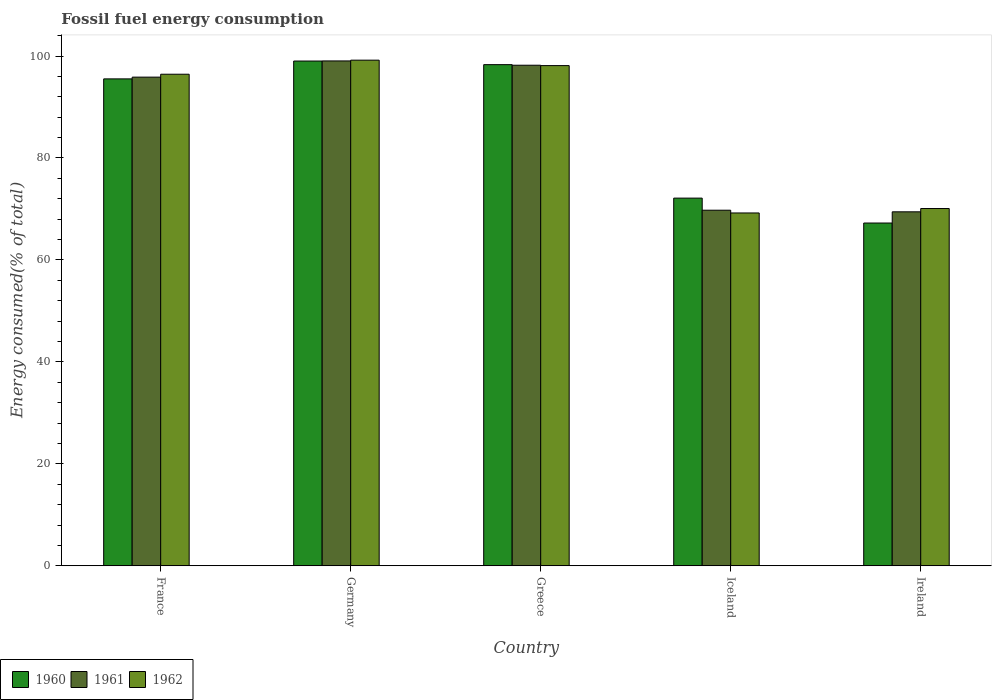How many different coloured bars are there?
Make the answer very short. 3. Are the number of bars per tick equal to the number of legend labels?
Your response must be concise. Yes. How many bars are there on the 1st tick from the right?
Provide a short and direct response. 3. What is the label of the 2nd group of bars from the left?
Make the answer very short. Germany. What is the percentage of energy consumed in 1960 in Ireland?
Give a very brief answer. 67.24. Across all countries, what is the maximum percentage of energy consumed in 1962?
Keep it short and to the point. 99.19. Across all countries, what is the minimum percentage of energy consumed in 1961?
Your answer should be very brief. 69.44. In which country was the percentage of energy consumed in 1961 maximum?
Provide a succinct answer. Germany. In which country was the percentage of energy consumed in 1961 minimum?
Offer a terse response. Ireland. What is the total percentage of energy consumed in 1961 in the graph?
Provide a succinct answer. 432.3. What is the difference between the percentage of energy consumed in 1962 in France and that in Iceland?
Offer a very short reply. 27.22. What is the difference between the percentage of energy consumed in 1961 in France and the percentage of energy consumed in 1960 in Greece?
Give a very brief answer. -2.45. What is the average percentage of energy consumed in 1960 per country?
Your answer should be compact. 86.44. What is the difference between the percentage of energy consumed of/in 1961 and percentage of energy consumed of/in 1960 in Iceland?
Ensure brevity in your answer.  -2.37. What is the ratio of the percentage of energy consumed in 1960 in Iceland to that in Ireland?
Provide a short and direct response. 1.07. What is the difference between the highest and the second highest percentage of energy consumed in 1962?
Ensure brevity in your answer.  -1.69. What is the difference between the highest and the lowest percentage of energy consumed in 1961?
Ensure brevity in your answer.  29.6. What does the 1st bar from the right in Ireland represents?
Your response must be concise. 1962. Is it the case that in every country, the sum of the percentage of energy consumed in 1961 and percentage of energy consumed in 1960 is greater than the percentage of energy consumed in 1962?
Your answer should be compact. Yes. How many countries are there in the graph?
Keep it short and to the point. 5. What is the difference between two consecutive major ticks on the Y-axis?
Your answer should be very brief. 20. Are the values on the major ticks of Y-axis written in scientific E-notation?
Ensure brevity in your answer.  No. Does the graph contain any zero values?
Provide a short and direct response. No. Does the graph contain grids?
Keep it short and to the point. No. How many legend labels are there?
Keep it short and to the point. 3. What is the title of the graph?
Ensure brevity in your answer.  Fossil fuel energy consumption. Does "1978" appear as one of the legend labels in the graph?
Your response must be concise. No. What is the label or title of the Y-axis?
Make the answer very short. Energy consumed(% of total). What is the Energy consumed(% of total) of 1960 in France?
Your answer should be compact. 95.52. What is the Energy consumed(% of total) in 1961 in France?
Give a very brief answer. 95.86. What is the Energy consumed(% of total) of 1962 in France?
Your answer should be very brief. 96.43. What is the Energy consumed(% of total) in 1960 in Germany?
Keep it short and to the point. 99.02. What is the Energy consumed(% of total) in 1961 in Germany?
Your answer should be very brief. 99.04. What is the Energy consumed(% of total) of 1962 in Germany?
Offer a very short reply. 99.19. What is the Energy consumed(% of total) in 1960 in Greece?
Your answer should be compact. 98.31. What is the Energy consumed(% of total) in 1961 in Greece?
Offer a very short reply. 98.2. What is the Energy consumed(% of total) of 1962 in Greece?
Offer a terse response. 98.12. What is the Energy consumed(% of total) in 1960 in Iceland?
Keep it short and to the point. 72.13. What is the Energy consumed(% of total) of 1961 in Iceland?
Ensure brevity in your answer.  69.76. What is the Energy consumed(% of total) in 1962 in Iceland?
Your answer should be very brief. 69.22. What is the Energy consumed(% of total) of 1960 in Ireland?
Provide a short and direct response. 67.24. What is the Energy consumed(% of total) in 1961 in Ireland?
Keep it short and to the point. 69.44. What is the Energy consumed(% of total) of 1962 in Ireland?
Ensure brevity in your answer.  70.09. Across all countries, what is the maximum Energy consumed(% of total) of 1960?
Ensure brevity in your answer.  99.02. Across all countries, what is the maximum Energy consumed(% of total) in 1961?
Offer a very short reply. 99.04. Across all countries, what is the maximum Energy consumed(% of total) in 1962?
Offer a very short reply. 99.19. Across all countries, what is the minimum Energy consumed(% of total) of 1960?
Provide a succinct answer. 67.24. Across all countries, what is the minimum Energy consumed(% of total) in 1961?
Provide a short and direct response. 69.44. Across all countries, what is the minimum Energy consumed(% of total) of 1962?
Make the answer very short. 69.22. What is the total Energy consumed(% of total) of 1960 in the graph?
Your answer should be very brief. 432.22. What is the total Energy consumed(% of total) of 1961 in the graph?
Give a very brief answer. 432.3. What is the total Energy consumed(% of total) of 1962 in the graph?
Offer a very short reply. 433.05. What is the difference between the Energy consumed(% of total) of 1961 in France and that in Germany?
Offer a very short reply. -3.18. What is the difference between the Energy consumed(% of total) of 1962 in France and that in Germany?
Provide a succinct answer. -2.76. What is the difference between the Energy consumed(% of total) in 1960 in France and that in Greece?
Offer a very short reply. -2.79. What is the difference between the Energy consumed(% of total) of 1961 in France and that in Greece?
Offer a terse response. -2.34. What is the difference between the Energy consumed(% of total) of 1962 in France and that in Greece?
Your response must be concise. -1.69. What is the difference between the Energy consumed(% of total) of 1960 in France and that in Iceland?
Ensure brevity in your answer.  23.39. What is the difference between the Energy consumed(% of total) in 1961 in France and that in Iceland?
Provide a short and direct response. 26.11. What is the difference between the Energy consumed(% of total) in 1962 in France and that in Iceland?
Your answer should be very brief. 27.22. What is the difference between the Energy consumed(% of total) in 1960 in France and that in Ireland?
Provide a short and direct response. 28.28. What is the difference between the Energy consumed(% of total) of 1961 in France and that in Ireland?
Provide a short and direct response. 26.42. What is the difference between the Energy consumed(% of total) in 1962 in France and that in Ireland?
Make the answer very short. 26.35. What is the difference between the Energy consumed(% of total) of 1960 in Germany and that in Greece?
Your answer should be very brief. 0.71. What is the difference between the Energy consumed(% of total) in 1961 in Germany and that in Greece?
Provide a succinct answer. 0.84. What is the difference between the Energy consumed(% of total) of 1962 in Germany and that in Greece?
Give a very brief answer. 1.07. What is the difference between the Energy consumed(% of total) of 1960 in Germany and that in Iceland?
Your response must be concise. 26.89. What is the difference between the Energy consumed(% of total) in 1961 in Germany and that in Iceland?
Give a very brief answer. 29.28. What is the difference between the Energy consumed(% of total) of 1962 in Germany and that in Iceland?
Your response must be concise. 29.98. What is the difference between the Energy consumed(% of total) of 1960 in Germany and that in Ireland?
Give a very brief answer. 31.78. What is the difference between the Energy consumed(% of total) in 1961 in Germany and that in Ireland?
Ensure brevity in your answer.  29.6. What is the difference between the Energy consumed(% of total) of 1962 in Germany and that in Ireland?
Your answer should be compact. 29.11. What is the difference between the Energy consumed(% of total) of 1960 in Greece and that in Iceland?
Provide a short and direct response. 26.18. What is the difference between the Energy consumed(% of total) in 1961 in Greece and that in Iceland?
Ensure brevity in your answer.  28.44. What is the difference between the Energy consumed(% of total) in 1962 in Greece and that in Iceland?
Make the answer very short. 28.91. What is the difference between the Energy consumed(% of total) in 1960 in Greece and that in Ireland?
Your response must be concise. 31.07. What is the difference between the Energy consumed(% of total) of 1961 in Greece and that in Ireland?
Make the answer very short. 28.76. What is the difference between the Energy consumed(% of total) of 1962 in Greece and that in Ireland?
Offer a very short reply. 28.04. What is the difference between the Energy consumed(% of total) in 1960 in Iceland and that in Ireland?
Provide a succinct answer. 4.89. What is the difference between the Energy consumed(% of total) of 1961 in Iceland and that in Ireland?
Make the answer very short. 0.32. What is the difference between the Energy consumed(% of total) of 1962 in Iceland and that in Ireland?
Give a very brief answer. -0.87. What is the difference between the Energy consumed(% of total) in 1960 in France and the Energy consumed(% of total) in 1961 in Germany?
Provide a succinct answer. -3.52. What is the difference between the Energy consumed(% of total) in 1960 in France and the Energy consumed(% of total) in 1962 in Germany?
Offer a very short reply. -3.67. What is the difference between the Energy consumed(% of total) in 1961 in France and the Energy consumed(% of total) in 1962 in Germany?
Your answer should be very brief. -3.33. What is the difference between the Energy consumed(% of total) of 1960 in France and the Energy consumed(% of total) of 1961 in Greece?
Your answer should be compact. -2.68. What is the difference between the Energy consumed(% of total) of 1960 in France and the Energy consumed(% of total) of 1962 in Greece?
Offer a terse response. -2.6. What is the difference between the Energy consumed(% of total) of 1961 in France and the Energy consumed(% of total) of 1962 in Greece?
Keep it short and to the point. -2.26. What is the difference between the Energy consumed(% of total) in 1960 in France and the Energy consumed(% of total) in 1961 in Iceland?
Offer a terse response. 25.76. What is the difference between the Energy consumed(% of total) in 1960 in France and the Energy consumed(% of total) in 1962 in Iceland?
Keep it short and to the point. 26.3. What is the difference between the Energy consumed(% of total) of 1961 in France and the Energy consumed(% of total) of 1962 in Iceland?
Provide a succinct answer. 26.64. What is the difference between the Energy consumed(% of total) of 1960 in France and the Energy consumed(% of total) of 1961 in Ireland?
Offer a very short reply. 26.08. What is the difference between the Energy consumed(% of total) in 1960 in France and the Energy consumed(% of total) in 1962 in Ireland?
Keep it short and to the point. 25.43. What is the difference between the Energy consumed(% of total) of 1961 in France and the Energy consumed(% of total) of 1962 in Ireland?
Provide a succinct answer. 25.78. What is the difference between the Energy consumed(% of total) in 1960 in Germany and the Energy consumed(% of total) in 1961 in Greece?
Your answer should be very brief. 0.82. What is the difference between the Energy consumed(% of total) in 1960 in Germany and the Energy consumed(% of total) in 1962 in Greece?
Make the answer very short. 0.9. What is the difference between the Energy consumed(% of total) in 1961 in Germany and the Energy consumed(% of total) in 1962 in Greece?
Provide a short and direct response. 0.92. What is the difference between the Energy consumed(% of total) of 1960 in Germany and the Energy consumed(% of total) of 1961 in Iceland?
Make the answer very short. 29.26. What is the difference between the Energy consumed(% of total) in 1960 in Germany and the Energy consumed(% of total) in 1962 in Iceland?
Your answer should be compact. 29.8. What is the difference between the Energy consumed(% of total) of 1961 in Germany and the Energy consumed(% of total) of 1962 in Iceland?
Give a very brief answer. 29.82. What is the difference between the Energy consumed(% of total) in 1960 in Germany and the Energy consumed(% of total) in 1961 in Ireland?
Provide a succinct answer. 29.58. What is the difference between the Energy consumed(% of total) in 1960 in Germany and the Energy consumed(% of total) in 1962 in Ireland?
Your response must be concise. 28.93. What is the difference between the Energy consumed(% of total) of 1961 in Germany and the Energy consumed(% of total) of 1962 in Ireland?
Provide a short and direct response. 28.96. What is the difference between the Energy consumed(% of total) of 1960 in Greece and the Energy consumed(% of total) of 1961 in Iceland?
Offer a terse response. 28.55. What is the difference between the Energy consumed(% of total) of 1960 in Greece and the Energy consumed(% of total) of 1962 in Iceland?
Provide a short and direct response. 29.09. What is the difference between the Energy consumed(% of total) in 1961 in Greece and the Energy consumed(% of total) in 1962 in Iceland?
Your answer should be very brief. 28.98. What is the difference between the Energy consumed(% of total) of 1960 in Greece and the Energy consumed(% of total) of 1961 in Ireland?
Provide a short and direct response. 28.87. What is the difference between the Energy consumed(% of total) of 1960 in Greece and the Energy consumed(% of total) of 1962 in Ireland?
Offer a terse response. 28.23. What is the difference between the Energy consumed(% of total) in 1961 in Greece and the Energy consumed(% of total) in 1962 in Ireland?
Provide a succinct answer. 28.11. What is the difference between the Energy consumed(% of total) in 1960 in Iceland and the Energy consumed(% of total) in 1961 in Ireland?
Give a very brief answer. 2.69. What is the difference between the Energy consumed(% of total) of 1960 in Iceland and the Energy consumed(% of total) of 1962 in Ireland?
Offer a very short reply. 2.04. What is the difference between the Energy consumed(% of total) of 1961 in Iceland and the Energy consumed(% of total) of 1962 in Ireland?
Keep it short and to the point. -0.33. What is the average Energy consumed(% of total) in 1960 per country?
Give a very brief answer. 86.44. What is the average Energy consumed(% of total) of 1961 per country?
Make the answer very short. 86.46. What is the average Energy consumed(% of total) of 1962 per country?
Provide a short and direct response. 86.61. What is the difference between the Energy consumed(% of total) in 1960 and Energy consumed(% of total) in 1961 in France?
Give a very brief answer. -0.34. What is the difference between the Energy consumed(% of total) in 1960 and Energy consumed(% of total) in 1962 in France?
Offer a very short reply. -0.91. What is the difference between the Energy consumed(% of total) of 1961 and Energy consumed(% of total) of 1962 in France?
Keep it short and to the point. -0.57. What is the difference between the Energy consumed(% of total) of 1960 and Energy consumed(% of total) of 1961 in Germany?
Provide a short and direct response. -0.02. What is the difference between the Energy consumed(% of total) of 1960 and Energy consumed(% of total) of 1962 in Germany?
Give a very brief answer. -0.17. What is the difference between the Energy consumed(% of total) of 1961 and Energy consumed(% of total) of 1962 in Germany?
Give a very brief answer. -0.15. What is the difference between the Energy consumed(% of total) in 1960 and Energy consumed(% of total) in 1961 in Greece?
Make the answer very short. 0.11. What is the difference between the Energy consumed(% of total) in 1960 and Energy consumed(% of total) in 1962 in Greece?
Your answer should be compact. 0.19. What is the difference between the Energy consumed(% of total) of 1961 and Energy consumed(% of total) of 1962 in Greece?
Provide a succinct answer. 0.07. What is the difference between the Energy consumed(% of total) of 1960 and Energy consumed(% of total) of 1961 in Iceland?
Make the answer very short. 2.37. What is the difference between the Energy consumed(% of total) in 1960 and Energy consumed(% of total) in 1962 in Iceland?
Give a very brief answer. 2.91. What is the difference between the Energy consumed(% of total) of 1961 and Energy consumed(% of total) of 1962 in Iceland?
Your response must be concise. 0.54. What is the difference between the Energy consumed(% of total) of 1960 and Energy consumed(% of total) of 1961 in Ireland?
Offer a very short reply. -2.2. What is the difference between the Energy consumed(% of total) in 1960 and Energy consumed(% of total) in 1962 in Ireland?
Your answer should be very brief. -2.84. What is the difference between the Energy consumed(% of total) of 1961 and Energy consumed(% of total) of 1962 in Ireland?
Offer a very short reply. -0.65. What is the ratio of the Energy consumed(% of total) of 1960 in France to that in Germany?
Give a very brief answer. 0.96. What is the ratio of the Energy consumed(% of total) of 1961 in France to that in Germany?
Provide a succinct answer. 0.97. What is the ratio of the Energy consumed(% of total) in 1962 in France to that in Germany?
Make the answer very short. 0.97. What is the ratio of the Energy consumed(% of total) of 1960 in France to that in Greece?
Your answer should be compact. 0.97. What is the ratio of the Energy consumed(% of total) of 1961 in France to that in Greece?
Provide a short and direct response. 0.98. What is the ratio of the Energy consumed(% of total) of 1962 in France to that in Greece?
Give a very brief answer. 0.98. What is the ratio of the Energy consumed(% of total) of 1960 in France to that in Iceland?
Provide a short and direct response. 1.32. What is the ratio of the Energy consumed(% of total) of 1961 in France to that in Iceland?
Offer a terse response. 1.37. What is the ratio of the Energy consumed(% of total) in 1962 in France to that in Iceland?
Provide a succinct answer. 1.39. What is the ratio of the Energy consumed(% of total) in 1960 in France to that in Ireland?
Your answer should be very brief. 1.42. What is the ratio of the Energy consumed(% of total) in 1961 in France to that in Ireland?
Offer a terse response. 1.38. What is the ratio of the Energy consumed(% of total) in 1962 in France to that in Ireland?
Your answer should be compact. 1.38. What is the ratio of the Energy consumed(% of total) of 1960 in Germany to that in Greece?
Provide a short and direct response. 1.01. What is the ratio of the Energy consumed(% of total) of 1961 in Germany to that in Greece?
Offer a very short reply. 1.01. What is the ratio of the Energy consumed(% of total) of 1962 in Germany to that in Greece?
Your answer should be very brief. 1.01. What is the ratio of the Energy consumed(% of total) in 1960 in Germany to that in Iceland?
Offer a very short reply. 1.37. What is the ratio of the Energy consumed(% of total) in 1961 in Germany to that in Iceland?
Your answer should be compact. 1.42. What is the ratio of the Energy consumed(% of total) in 1962 in Germany to that in Iceland?
Offer a very short reply. 1.43. What is the ratio of the Energy consumed(% of total) of 1960 in Germany to that in Ireland?
Your response must be concise. 1.47. What is the ratio of the Energy consumed(% of total) of 1961 in Germany to that in Ireland?
Your answer should be very brief. 1.43. What is the ratio of the Energy consumed(% of total) of 1962 in Germany to that in Ireland?
Your answer should be very brief. 1.42. What is the ratio of the Energy consumed(% of total) of 1960 in Greece to that in Iceland?
Ensure brevity in your answer.  1.36. What is the ratio of the Energy consumed(% of total) in 1961 in Greece to that in Iceland?
Keep it short and to the point. 1.41. What is the ratio of the Energy consumed(% of total) in 1962 in Greece to that in Iceland?
Provide a short and direct response. 1.42. What is the ratio of the Energy consumed(% of total) in 1960 in Greece to that in Ireland?
Give a very brief answer. 1.46. What is the ratio of the Energy consumed(% of total) of 1961 in Greece to that in Ireland?
Offer a very short reply. 1.41. What is the ratio of the Energy consumed(% of total) of 1962 in Greece to that in Ireland?
Provide a succinct answer. 1.4. What is the ratio of the Energy consumed(% of total) in 1960 in Iceland to that in Ireland?
Offer a terse response. 1.07. What is the ratio of the Energy consumed(% of total) in 1962 in Iceland to that in Ireland?
Provide a succinct answer. 0.99. What is the difference between the highest and the second highest Energy consumed(% of total) of 1960?
Ensure brevity in your answer.  0.71. What is the difference between the highest and the second highest Energy consumed(% of total) in 1961?
Your answer should be compact. 0.84. What is the difference between the highest and the second highest Energy consumed(% of total) of 1962?
Offer a terse response. 1.07. What is the difference between the highest and the lowest Energy consumed(% of total) of 1960?
Your answer should be compact. 31.78. What is the difference between the highest and the lowest Energy consumed(% of total) in 1961?
Provide a succinct answer. 29.6. What is the difference between the highest and the lowest Energy consumed(% of total) of 1962?
Provide a short and direct response. 29.98. 